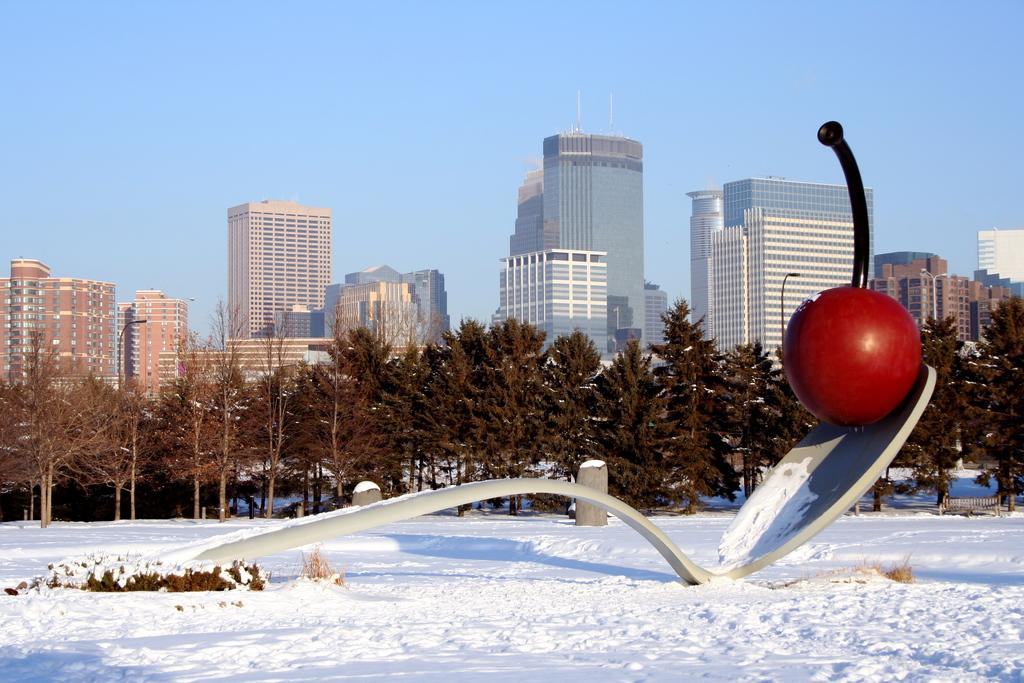What is the condition of the land in the image? The land in the image is covered with snow. What can be seen in the image besides the snow-covered land? There is an architectural structure, trees, buildings, and the sky visible in the image. Can you describe the architectural structure in the image? Unfortunately, the provided facts do not give enough detail to describe the architectural structure. What type of vegetation is visible in the background of the image? There are trees visible in the background of the image. What is visible in the sky in the image? The sky is visible in the background of the image, but the provided facts do not give enough detail to describe its condition. Where is the cactus located in the image? There is no cactus present in the image. What type of leather is visible on the trees in the image? There is no leather present on the trees in the image; they are covered with snow. 